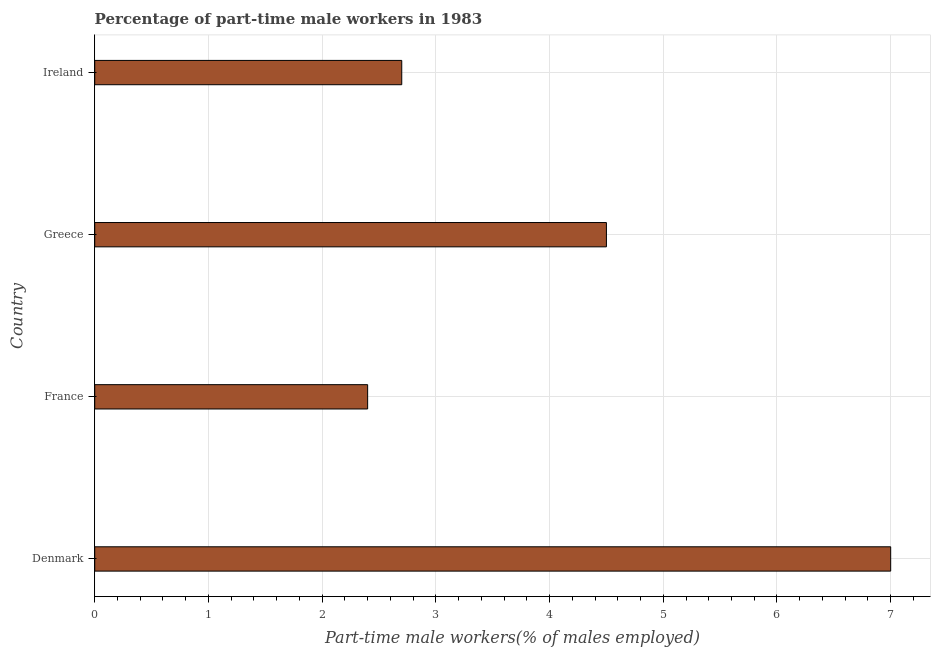Does the graph contain any zero values?
Offer a terse response. No. What is the title of the graph?
Your answer should be compact. Percentage of part-time male workers in 1983. What is the label or title of the X-axis?
Give a very brief answer. Part-time male workers(% of males employed). What is the label or title of the Y-axis?
Provide a succinct answer. Country. What is the percentage of part-time male workers in France?
Ensure brevity in your answer.  2.4. Across all countries, what is the maximum percentage of part-time male workers?
Your response must be concise. 7. Across all countries, what is the minimum percentage of part-time male workers?
Provide a succinct answer. 2.4. In which country was the percentage of part-time male workers maximum?
Your answer should be very brief. Denmark. In which country was the percentage of part-time male workers minimum?
Make the answer very short. France. What is the sum of the percentage of part-time male workers?
Give a very brief answer. 16.6. What is the difference between the percentage of part-time male workers in Greece and Ireland?
Offer a very short reply. 1.8. What is the average percentage of part-time male workers per country?
Provide a short and direct response. 4.15. What is the median percentage of part-time male workers?
Offer a terse response. 3.6. What is the ratio of the percentage of part-time male workers in Denmark to that in France?
Provide a short and direct response. 2.92. Is the percentage of part-time male workers in France less than that in Ireland?
Your response must be concise. Yes. What is the difference between the highest and the second highest percentage of part-time male workers?
Ensure brevity in your answer.  2.5. In how many countries, is the percentage of part-time male workers greater than the average percentage of part-time male workers taken over all countries?
Make the answer very short. 2. How many countries are there in the graph?
Make the answer very short. 4. What is the difference between two consecutive major ticks on the X-axis?
Ensure brevity in your answer.  1. What is the Part-time male workers(% of males employed) of Denmark?
Offer a very short reply. 7. What is the Part-time male workers(% of males employed) of France?
Your response must be concise. 2.4. What is the Part-time male workers(% of males employed) of Ireland?
Keep it short and to the point. 2.7. What is the difference between the Part-time male workers(% of males employed) in Denmark and France?
Offer a very short reply. 4.6. What is the difference between the Part-time male workers(% of males employed) in Denmark and Greece?
Provide a succinct answer. 2.5. What is the ratio of the Part-time male workers(% of males employed) in Denmark to that in France?
Keep it short and to the point. 2.92. What is the ratio of the Part-time male workers(% of males employed) in Denmark to that in Greece?
Offer a very short reply. 1.56. What is the ratio of the Part-time male workers(% of males employed) in Denmark to that in Ireland?
Make the answer very short. 2.59. What is the ratio of the Part-time male workers(% of males employed) in France to that in Greece?
Keep it short and to the point. 0.53. What is the ratio of the Part-time male workers(% of males employed) in France to that in Ireland?
Offer a very short reply. 0.89. What is the ratio of the Part-time male workers(% of males employed) in Greece to that in Ireland?
Make the answer very short. 1.67. 